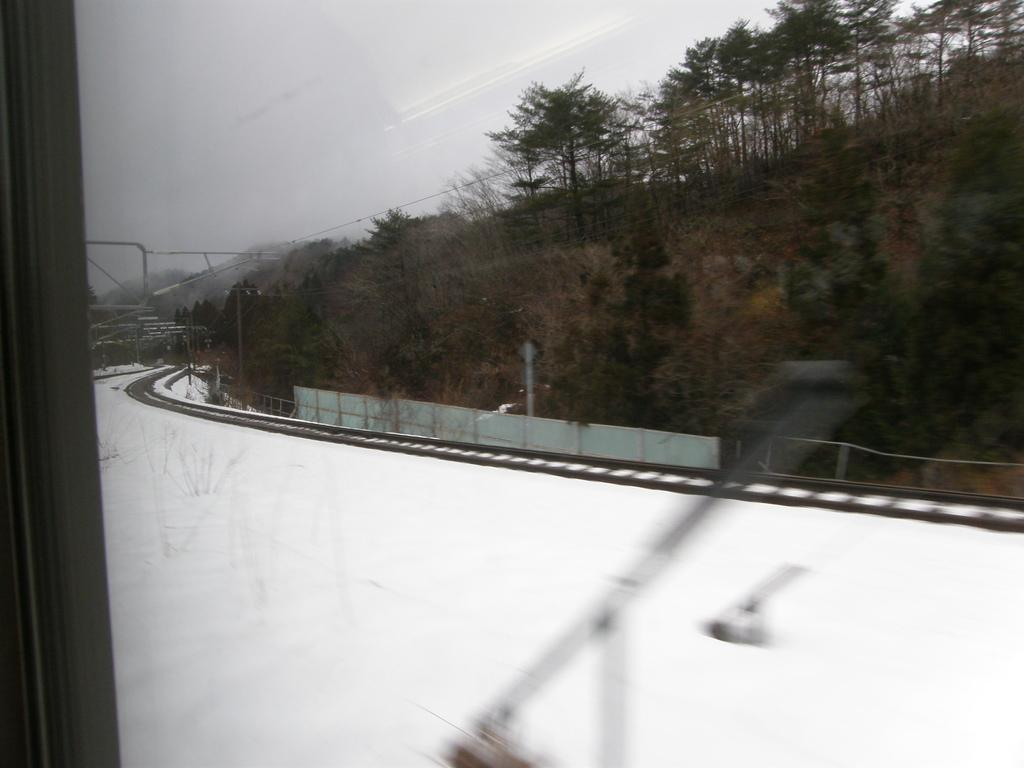What type of structure is present on the left side of the image? There is a glass window in the image. What can be seen in the middle of the image? There is a railway track in the middle of the image. What type of vegetation is on the right side of the image? There are trees on the right side of the image. What is visible at the top of the image? The sky is visible at the top of the image. How many whips can be seen in the image? There are no whips present in the image. What color is the stomach of the person in the image? There is no person present in the image, so it is not possible to determine the color of their stomach. 